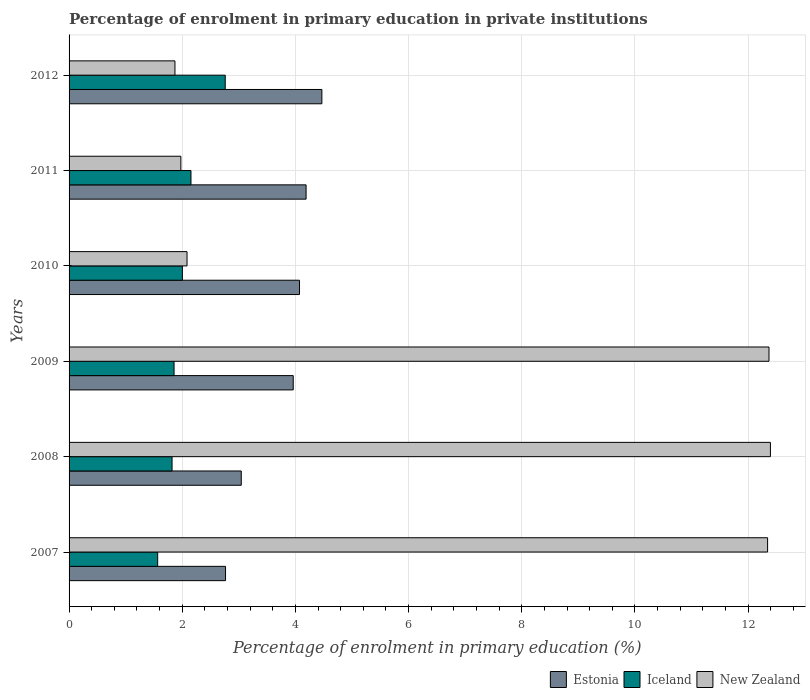How many groups of bars are there?
Your answer should be very brief. 6. Are the number of bars on each tick of the Y-axis equal?
Keep it short and to the point. Yes. In how many cases, is the number of bars for a given year not equal to the number of legend labels?
Ensure brevity in your answer.  0. What is the percentage of enrolment in primary education in New Zealand in 2007?
Make the answer very short. 12.34. Across all years, what is the maximum percentage of enrolment in primary education in Iceland?
Offer a very short reply. 2.76. Across all years, what is the minimum percentage of enrolment in primary education in Iceland?
Provide a short and direct response. 1.57. In which year was the percentage of enrolment in primary education in Estonia maximum?
Your response must be concise. 2012. In which year was the percentage of enrolment in primary education in Estonia minimum?
Keep it short and to the point. 2007. What is the total percentage of enrolment in primary education in Iceland in the graph?
Your answer should be compact. 12.16. What is the difference between the percentage of enrolment in primary education in Estonia in 2007 and that in 2012?
Keep it short and to the point. -1.7. What is the difference between the percentage of enrolment in primary education in Estonia in 2009 and the percentage of enrolment in primary education in New Zealand in 2008?
Your response must be concise. -8.43. What is the average percentage of enrolment in primary education in Estonia per year?
Keep it short and to the point. 3.75. In the year 2012, what is the difference between the percentage of enrolment in primary education in New Zealand and percentage of enrolment in primary education in Estonia?
Ensure brevity in your answer.  -2.6. What is the ratio of the percentage of enrolment in primary education in New Zealand in 2009 to that in 2012?
Keep it short and to the point. 6.61. What is the difference between the highest and the second highest percentage of enrolment in primary education in Iceland?
Ensure brevity in your answer.  0.61. What is the difference between the highest and the lowest percentage of enrolment in primary education in Estonia?
Your answer should be very brief. 1.7. In how many years, is the percentage of enrolment in primary education in Estonia greater than the average percentage of enrolment in primary education in Estonia taken over all years?
Offer a very short reply. 4. What does the 3rd bar from the bottom in 2011 represents?
Offer a very short reply. New Zealand. Is it the case that in every year, the sum of the percentage of enrolment in primary education in Iceland and percentage of enrolment in primary education in Estonia is greater than the percentage of enrolment in primary education in New Zealand?
Your response must be concise. No. What is the difference between two consecutive major ticks on the X-axis?
Make the answer very short. 2. Does the graph contain any zero values?
Your answer should be very brief. No. What is the title of the graph?
Give a very brief answer. Percentage of enrolment in primary education in private institutions. Does "Tanzania" appear as one of the legend labels in the graph?
Provide a succinct answer. No. What is the label or title of the X-axis?
Keep it short and to the point. Percentage of enrolment in primary education (%). What is the label or title of the Y-axis?
Your response must be concise. Years. What is the Percentage of enrolment in primary education (%) in Estonia in 2007?
Offer a very short reply. 2.76. What is the Percentage of enrolment in primary education (%) of Iceland in 2007?
Keep it short and to the point. 1.57. What is the Percentage of enrolment in primary education (%) in New Zealand in 2007?
Give a very brief answer. 12.34. What is the Percentage of enrolment in primary education (%) in Estonia in 2008?
Keep it short and to the point. 3.04. What is the Percentage of enrolment in primary education (%) in Iceland in 2008?
Provide a succinct answer. 1.82. What is the Percentage of enrolment in primary education (%) of New Zealand in 2008?
Your answer should be very brief. 12.39. What is the Percentage of enrolment in primary education (%) of Estonia in 2009?
Give a very brief answer. 3.96. What is the Percentage of enrolment in primary education (%) of Iceland in 2009?
Your response must be concise. 1.86. What is the Percentage of enrolment in primary education (%) in New Zealand in 2009?
Keep it short and to the point. 12.37. What is the Percentage of enrolment in primary education (%) in Estonia in 2010?
Your response must be concise. 4.07. What is the Percentage of enrolment in primary education (%) of Iceland in 2010?
Make the answer very short. 2. What is the Percentage of enrolment in primary education (%) in New Zealand in 2010?
Ensure brevity in your answer.  2.08. What is the Percentage of enrolment in primary education (%) in Estonia in 2011?
Keep it short and to the point. 4.19. What is the Percentage of enrolment in primary education (%) in Iceland in 2011?
Offer a terse response. 2.15. What is the Percentage of enrolment in primary education (%) of New Zealand in 2011?
Offer a terse response. 1.98. What is the Percentage of enrolment in primary education (%) in Estonia in 2012?
Provide a short and direct response. 4.47. What is the Percentage of enrolment in primary education (%) of Iceland in 2012?
Offer a very short reply. 2.76. What is the Percentage of enrolment in primary education (%) of New Zealand in 2012?
Your response must be concise. 1.87. Across all years, what is the maximum Percentage of enrolment in primary education (%) of Estonia?
Offer a terse response. 4.47. Across all years, what is the maximum Percentage of enrolment in primary education (%) of Iceland?
Make the answer very short. 2.76. Across all years, what is the maximum Percentage of enrolment in primary education (%) of New Zealand?
Provide a short and direct response. 12.39. Across all years, what is the minimum Percentage of enrolment in primary education (%) in Estonia?
Provide a short and direct response. 2.76. Across all years, what is the minimum Percentage of enrolment in primary education (%) in Iceland?
Your response must be concise. 1.57. Across all years, what is the minimum Percentage of enrolment in primary education (%) in New Zealand?
Offer a very short reply. 1.87. What is the total Percentage of enrolment in primary education (%) of Estonia in the graph?
Provide a succinct answer. 22.5. What is the total Percentage of enrolment in primary education (%) in Iceland in the graph?
Your answer should be compact. 12.16. What is the total Percentage of enrolment in primary education (%) in New Zealand in the graph?
Provide a short and direct response. 43.04. What is the difference between the Percentage of enrolment in primary education (%) in Estonia in 2007 and that in 2008?
Provide a short and direct response. -0.28. What is the difference between the Percentage of enrolment in primary education (%) of Iceland in 2007 and that in 2008?
Make the answer very short. -0.25. What is the difference between the Percentage of enrolment in primary education (%) in New Zealand in 2007 and that in 2008?
Give a very brief answer. -0.05. What is the difference between the Percentage of enrolment in primary education (%) of Estonia in 2007 and that in 2009?
Make the answer very short. -1.2. What is the difference between the Percentage of enrolment in primary education (%) in Iceland in 2007 and that in 2009?
Your answer should be compact. -0.29. What is the difference between the Percentage of enrolment in primary education (%) of New Zealand in 2007 and that in 2009?
Make the answer very short. -0.02. What is the difference between the Percentage of enrolment in primary education (%) of Estonia in 2007 and that in 2010?
Provide a short and direct response. -1.31. What is the difference between the Percentage of enrolment in primary education (%) of Iceland in 2007 and that in 2010?
Ensure brevity in your answer.  -0.44. What is the difference between the Percentage of enrolment in primary education (%) in New Zealand in 2007 and that in 2010?
Your answer should be compact. 10.26. What is the difference between the Percentage of enrolment in primary education (%) in Estonia in 2007 and that in 2011?
Ensure brevity in your answer.  -1.42. What is the difference between the Percentage of enrolment in primary education (%) of Iceland in 2007 and that in 2011?
Your response must be concise. -0.59. What is the difference between the Percentage of enrolment in primary education (%) of New Zealand in 2007 and that in 2011?
Provide a succinct answer. 10.37. What is the difference between the Percentage of enrolment in primary education (%) in Estonia in 2007 and that in 2012?
Keep it short and to the point. -1.7. What is the difference between the Percentage of enrolment in primary education (%) of Iceland in 2007 and that in 2012?
Give a very brief answer. -1.19. What is the difference between the Percentage of enrolment in primary education (%) in New Zealand in 2007 and that in 2012?
Offer a very short reply. 10.47. What is the difference between the Percentage of enrolment in primary education (%) in Estonia in 2008 and that in 2009?
Offer a terse response. -0.92. What is the difference between the Percentage of enrolment in primary education (%) of Iceland in 2008 and that in 2009?
Make the answer very short. -0.04. What is the difference between the Percentage of enrolment in primary education (%) in New Zealand in 2008 and that in 2009?
Ensure brevity in your answer.  0.03. What is the difference between the Percentage of enrolment in primary education (%) in Estonia in 2008 and that in 2010?
Give a very brief answer. -1.03. What is the difference between the Percentage of enrolment in primary education (%) in Iceland in 2008 and that in 2010?
Your answer should be compact. -0.18. What is the difference between the Percentage of enrolment in primary education (%) of New Zealand in 2008 and that in 2010?
Make the answer very short. 10.31. What is the difference between the Percentage of enrolment in primary education (%) of Estonia in 2008 and that in 2011?
Keep it short and to the point. -1.15. What is the difference between the Percentage of enrolment in primary education (%) in Iceland in 2008 and that in 2011?
Make the answer very short. -0.33. What is the difference between the Percentage of enrolment in primary education (%) of New Zealand in 2008 and that in 2011?
Make the answer very short. 10.42. What is the difference between the Percentage of enrolment in primary education (%) in Estonia in 2008 and that in 2012?
Ensure brevity in your answer.  -1.42. What is the difference between the Percentage of enrolment in primary education (%) of Iceland in 2008 and that in 2012?
Ensure brevity in your answer.  -0.94. What is the difference between the Percentage of enrolment in primary education (%) of New Zealand in 2008 and that in 2012?
Offer a terse response. 10.52. What is the difference between the Percentage of enrolment in primary education (%) in Estonia in 2009 and that in 2010?
Your response must be concise. -0.11. What is the difference between the Percentage of enrolment in primary education (%) of Iceland in 2009 and that in 2010?
Keep it short and to the point. -0.15. What is the difference between the Percentage of enrolment in primary education (%) of New Zealand in 2009 and that in 2010?
Make the answer very short. 10.28. What is the difference between the Percentage of enrolment in primary education (%) in Estonia in 2009 and that in 2011?
Provide a succinct answer. -0.23. What is the difference between the Percentage of enrolment in primary education (%) of Iceland in 2009 and that in 2011?
Provide a succinct answer. -0.3. What is the difference between the Percentage of enrolment in primary education (%) in New Zealand in 2009 and that in 2011?
Provide a succinct answer. 10.39. What is the difference between the Percentage of enrolment in primary education (%) of Estonia in 2009 and that in 2012?
Provide a succinct answer. -0.51. What is the difference between the Percentage of enrolment in primary education (%) of Iceland in 2009 and that in 2012?
Your answer should be very brief. -0.9. What is the difference between the Percentage of enrolment in primary education (%) of New Zealand in 2009 and that in 2012?
Ensure brevity in your answer.  10.5. What is the difference between the Percentage of enrolment in primary education (%) of Estonia in 2010 and that in 2011?
Give a very brief answer. -0.12. What is the difference between the Percentage of enrolment in primary education (%) of Iceland in 2010 and that in 2011?
Offer a very short reply. -0.15. What is the difference between the Percentage of enrolment in primary education (%) in New Zealand in 2010 and that in 2011?
Make the answer very short. 0.11. What is the difference between the Percentage of enrolment in primary education (%) in Estonia in 2010 and that in 2012?
Offer a terse response. -0.4. What is the difference between the Percentage of enrolment in primary education (%) in Iceland in 2010 and that in 2012?
Make the answer very short. -0.76. What is the difference between the Percentage of enrolment in primary education (%) in New Zealand in 2010 and that in 2012?
Your answer should be very brief. 0.21. What is the difference between the Percentage of enrolment in primary education (%) of Estonia in 2011 and that in 2012?
Give a very brief answer. -0.28. What is the difference between the Percentage of enrolment in primary education (%) of Iceland in 2011 and that in 2012?
Give a very brief answer. -0.61. What is the difference between the Percentage of enrolment in primary education (%) in New Zealand in 2011 and that in 2012?
Offer a terse response. 0.1. What is the difference between the Percentage of enrolment in primary education (%) in Estonia in 2007 and the Percentage of enrolment in primary education (%) in Iceland in 2008?
Offer a very short reply. 0.94. What is the difference between the Percentage of enrolment in primary education (%) in Estonia in 2007 and the Percentage of enrolment in primary education (%) in New Zealand in 2008?
Make the answer very short. -9.63. What is the difference between the Percentage of enrolment in primary education (%) in Iceland in 2007 and the Percentage of enrolment in primary education (%) in New Zealand in 2008?
Make the answer very short. -10.83. What is the difference between the Percentage of enrolment in primary education (%) in Estonia in 2007 and the Percentage of enrolment in primary education (%) in Iceland in 2009?
Provide a succinct answer. 0.91. What is the difference between the Percentage of enrolment in primary education (%) of Estonia in 2007 and the Percentage of enrolment in primary education (%) of New Zealand in 2009?
Your answer should be very brief. -9.6. What is the difference between the Percentage of enrolment in primary education (%) of Iceland in 2007 and the Percentage of enrolment in primary education (%) of New Zealand in 2009?
Provide a short and direct response. -10.8. What is the difference between the Percentage of enrolment in primary education (%) in Estonia in 2007 and the Percentage of enrolment in primary education (%) in Iceland in 2010?
Your answer should be very brief. 0.76. What is the difference between the Percentage of enrolment in primary education (%) in Estonia in 2007 and the Percentage of enrolment in primary education (%) in New Zealand in 2010?
Keep it short and to the point. 0.68. What is the difference between the Percentage of enrolment in primary education (%) of Iceland in 2007 and the Percentage of enrolment in primary education (%) of New Zealand in 2010?
Your answer should be compact. -0.52. What is the difference between the Percentage of enrolment in primary education (%) in Estonia in 2007 and the Percentage of enrolment in primary education (%) in Iceland in 2011?
Offer a very short reply. 0.61. What is the difference between the Percentage of enrolment in primary education (%) of Estonia in 2007 and the Percentage of enrolment in primary education (%) of New Zealand in 2011?
Provide a short and direct response. 0.79. What is the difference between the Percentage of enrolment in primary education (%) of Iceland in 2007 and the Percentage of enrolment in primary education (%) of New Zealand in 2011?
Provide a short and direct response. -0.41. What is the difference between the Percentage of enrolment in primary education (%) of Estonia in 2007 and the Percentage of enrolment in primary education (%) of Iceland in 2012?
Offer a terse response. 0.01. What is the difference between the Percentage of enrolment in primary education (%) of Estonia in 2007 and the Percentage of enrolment in primary education (%) of New Zealand in 2012?
Give a very brief answer. 0.89. What is the difference between the Percentage of enrolment in primary education (%) in Iceland in 2007 and the Percentage of enrolment in primary education (%) in New Zealand in 2012?
Give a very brief answer. -0.31. What is the difference between the Percentage of enrolment in primary education (%) of Estonia in 2008 and the Percentage of enrolment in primary education (%) of Iceland in 2009?
Ensure brevity in your answer.  1.19. What is the difference between the Percentage of enrolment in primary education (%) in Estonia in 2008 and the Percentage of enrolment in primary education (%) in New Zealand in 2009?
Make the answer very short. -9.33. What is the difference between the Percentage of enrolment in primary education (%) in Iceland in 2008 and the Percentage of enrolment in primary education (%) in New Zealand in 2009?
Ensure brevity in your answer.  -10.55. What is the difference between the Percentage of enrolment in primary education (%) in Estonia in 2008 and the Percentage of enrolment in primary education (%) in Iceland in 2010?
Make the answer very short. 1.04. What is the difference between the Percentage of enrolment in primary education (%) in Estonia in 2008 and the Percentage of enrolment in primary education (%) in New Zealand in 2010?
Your answer should be compact. 0.96. What is the difference between the Percentage of enrolment in primary education (%) of Iceland in 2008 and the Percentage of enrolment in primary education (%) of New Zealand in 2010?
Keep it short and to the point. -0.26. What is the difference between the Percentage of enrolment in primary education (%) in Estonia in 2008 and the Percentage of enrolment in primary education (%) in New Zealand in 2011?
Provide a short and direct response. 1.07. What is the difference between the Percentage of enrolment in primary education (%) in Iceland in 2008 and the Percentage of enrolment in primary education (%) in New Zealand in 2011?
Provide a succinct answer. -0.16. What is the difference between the Percentage of enrolment in primary education (%) in Estonia in 2008 and the Percentage of enrolment in primary education (%) in Iceland in 2012?
Offer a very short reply. 0.28. What is the difference between the Percentage of enrolment in primary education (%) in Estonia in 2008 and the Percentage of enrolment in primary education (%) in New Zealand in 2012?
Ensure brevity in your answer.  1.17. What is the difference between the Percentage of enrolment in primary education (%) in Iceland in 2008 and the Percentage of enrolment in primary education (%) in New Zealand in 2012?
Ensure brevity in your answer.  -0.05. What is the difference between the Percentage of enrolment in primary education (%) of Estonia in 2009 and the Percentage of enrolment in primary education (%) of Iceland in 2010?
Offer a terse response. 1.96. What is the difference between the Percentage of enrolment in primary education (%) in Estonia in 2009 and the Percentage of enrolment in primary education (%) in New Zealand in 2010?
Offer a very short reply. 1.88. What is the difference between the Percentage of enrolment in primary education (%) in Iceland in 2009 and the Percentage of enrolment in primary education (%) in New Zealand in 2010?
Provide a succinct answer. -0.23. What is the difference between the Percentage of enrolment in primary education (%) of Estonia in 2009 and the Percentage of enrolment in primary education (%) of Iceland in 2011?
Your answer should be compact. 1.81. What is the difference between the Percentage of enrolment in primary education (%) of Estonia in 2009 and the Percentage of enrolment in primary education (%) of New Zealand in 2011?
Give a very brief answer. 1.99. What is the difference between the Percentage of enrolment in primary education (%) in Iceland in 2009 and the Percentage of enrolment in primary education (%) in New Zealand in 2011?
Provide a short and direct response. -0.12. What is the difference between the Percentage of enrolment in primary education (%) in Estonia in 2009 and the Percentage of enrolment in primary education (%) in Iceland in 2012?
Make the answer very short. 1.2. What is the difference between the Percentage of enrolment in primary education (%) in Estonia in 2009 and the Percentage of enrolment in primary education (%) in New Zealand in 2012?
Your answer should be compact. 2.09. What is the difference between the Percentage of enrolment in primary education (%) of Iceland in 2009 and the Percentage of enrolment in primary education (%) of New Zealand in 2012?
Ensure brevity in your answer.  -0.02. What is the difference between the Percentage of enrolment in primary education (%) of Estonia in 2010 and the Percentage of enrolment in primary education (%) of Iceland in 2011?
Provide a short and direct response. 1.92. What is the difference between the Percentage of enrolment in primary education (%) of Estonia in 2010 and the Percentage of enrolment in primary education (%) of New Zealand in 2011?
Your answer should be very brief. 2.1. What is the difference between the Percentage of enrolment in primary education (%) of Iceland in 2010 and the Percentage of enrolment in primary education (%) of New Zealand in 2011?
Your answer should be compact. 0.03. What is the difference between the Percentage of enrolment in primary education (%) of Estonia in 2010 and the Percentage of enrolment in primary education (%) of Iceland in 2012?
Your answer should be very brief. 1.31. What is the difference between the Percentage of enrolment in primary education (%) in Estonia in 2010 and the Percentage of enrolment in primary education (%) in New Zealand in 2012?
Offer a terse response. 2.2. What is the difference between the Percentage of enrolment in primary education (%) of Iceland in 2010 and the Percentage of enrolment in primary education (%) of New Zealand in 2012?
Your response must be concise. 0.13. What is the difference between the Percentage of enrolment in primary education (%) in Estonia in 2011 and the Percentage of enrolment in primary education (%) in Iceland in 2012?
Your response must be concise. 1.43. What is the difference between the Percentage of enrolment in primary education (%) in Estonia in 2011 and the Percentage of enrolment in primary education (%) in New Zealand in 2012?
Make the answer very short. 2.32. What is the difference between the Percentage of enrolment in primary education (%) in Iceland in 2011 and the Percentage of enrolment in primary education (%) in New Zealand in 2012?
Make the answer very short. 0.28. What is the average Percentage of enrolment in primary education (%) in Estonia per year?
Provide a succinct answer. 3.75. What is the average Percentage of enrolment in primary education (%) in Iceland per year?
Your answer should be very brief. 2.03. What is the average Percentage of enrolment in primary education (%) in New Zealand per year?
Your response must be concise. 7.17. In the year 2007, what is the difference between the Percentage of enrolment in primary education (%) in Estonia and Percentage of enrolment in primary education (%) in Iceland?
Keep it short and to the point. 1.2. In the year 2007, what is the difference between the Percentage of enrolment in primary education (%) of Estonia and Percentage of enrolment in primary education (%) of New Zealand?
Your answer should be very brief. -9.58. In the year 2007, what is the difference between the Percentage of enrolment in primary education (%) of Iceland and Percentage of enrolment in primary education (%) of New Zealand?
Offer a terse response. -10.78. In the year 2008, what is the difference between the Percentage of enrolment in primary education (%) in Estonia and Percentage of enrolment in primary education (%) in Iceland?
Your response must be concise. 1.22. In the year 2008, what is the difference between the Percentage of enrolment in primary education (%) of Estonia and Percentage of enrolment in primary education (%) of New Zealand?
Offer a very short reply. -9.35. In the year 2008, what is the difference between the Percentage of enrolment in primary education (%) in Iceland and Percentage of enrolment in primary education (%) in New Zealand?
Offer a terse response. -10.57. In the year 2009, what is the difference between the Percentage of enrolment in primary education (%) in Estonia and Percentage of enrolment in primary education (%) in Iceland?
Make the answer very short. 2.11. In the year 2009, what is the difference between the Percentage of enrolment in primary education (%) in Estonia and Percentage of enrolment in primary education (%) in New Zealand?
Provide a short and direct response. -8.41. In the year 2009, what is the difference between the Percentage of enrolment in primary education (%) of Iceland and Percentage of enrolment in primary education (%) of New Zealand?
Offer a very short reply. -10.51. In the year 2010, what is the difference between the Percentage of enrolment in primary education (%) in Estonia and Percentage of enrolment in primary education (%) in Iceland?
Offer a terse response. 2.07. In the year 2010, what is the difference between the Percentage of enrolment in primary education (%) in Estonia and Percentage of enrolment in primary education (%) in New Zealand?
Make the answer very short. 1.99. In the year 2010, what is the difference between the Percentage of enrolment in primary education (%) in Iceland and Percentage of enrolment in primary education (%) in New Zealand?
Make the answer very short. -0.08. In the year 2011, what is the difference between the Percentage of enrolment in primary education (%) of Estonia and Percentage of enrolment in primary education (%) of Iceland?
Your answer should be very brief. 2.03. In the year 2011, what is the difference between the Percentage of enrolment in primary education (%) of Estonia and Percentage of enrolment in primary education (%) of New Zealand?
Offer a very short reply. 2.21. In the year 2011, what is the difference between the Percentage of enrolment in primary education (%) in Iceland and Percentage of enrolment in primary education (%) in New Zealand?
Keep it short and to the point. 0.18. In the year 2012, what is the difference between the Percentage of enrolment in primary education (%) in Estonia and Percentage of enrolment in primary education (%) in Iceland?
Provide a succinct answer. 1.71. In the year 2012, what is the difference between the Percentage of enrolment in primary education (%) of Estonia and Percentage of enrolment in primary education (%) of New Zealand?
Your response must be concise. 2.6. In the year 2012, what is the difference between the Percentage of enrolment in primary education (%) of Iceland and Percentage of enrolment in primary education (%) of New Zealand?
Give a very brief answer. 0.89. What is the ratio of the Percentage of enrolment in primary education (%) in Estonia in 2007 to that in 2008?
Provide a succinct answer. 0.91. What is the ratio of the Percentage of enrolment in primary education (%) of Iceland in 2007 to that in 2008?
Ensure brevity in your answer.  0.86. What is the ratio of the Percentage of enrolment in primary education (%) in New Zealand in 2007 to that in 2008?
Provide a short and direct response. 1. What is the ratio of the Percentage of enrolment in primary education (%) of Estonia in 2007 to that in 2009?
Your answer should be compact. 0.7. What is the ratio of the Percentage of enrolment in primary education (%) of Iceland in 2007 to that in 2009?
Your answer should be compact. 0.84. What is the ratio of the Percentage of enrolment in primary education (%) in Estonia in 2007 to that in 2010?
Your response must be concise. 0.68. What is the ratio of the Percentage of enrolment in primary education (%) of Iceland in 2007 to that in 2010?
Offer a terse response. 0.78. What is the ratio of the Percentage of enrolment in primary education (%) of New Zealand in 2007 to that in 2010?
Your answer should be compact. 5.92. What is the ratio of the Percentage of enrolment in primary education (%) of Estonia in 2007 to that in 2011?
Provide a succinct answer. 0.66. What is the ratio of the Percentage of enrolment in primary education (%) in Iceland in 2007 to that in 2011?
Provide a succinct answer. 0.73. What is the ratio of the Percentage of enrolment in primary education (%) in New Zealand in 2007 to that in 2011?
Provide a succinct answer. 6.25. What is the ratio of the Percentage of enrolment in primary education (%) of Estonia in 2007 to that in 2012?
Give a very brief answer. 0.62. What is the ratio of the Percentage of enrolment in primary education (%) in Iceland in 2007 to that in 2012?
Provide a short and direct response. 0.57. What is the ratio of the Percentage of enrolment in primary education (%) of New Zealand in 2007 to that in 2012?
Make the answer very short. 6.6. What is the ratio of the Percentage of enrolment in primary education (%) in Estonia in 2008 to that in 2009?
Your response must be concise. 0.77. What is the ratio of the Percentage of enrolment in primary education (%) of Estonia in 2008 to that in 2010?
Offer a terse response. 0.75. What is the ratio of the Percentage of enrolment in primary education (%) in Iceland in 2008 to that in 2010?
Your response must be concise. 0.91. What is the ratio of the Percentage of enrolment in primary education (%) in New Zealand in 2008 to that in 2010?
Offer a very short reply. 5.95. What is the ratio of the Percentage of enrolment in primary education (%) of Estonia in 2008 to that in 2011?
Give a very brief answer. 0.73. What is the ratio of the Percentage of enrolment in primary education (%) in Iceland in 2008 to that in 2011?
Provide a short and direct response. 0.84. What is the ratio of the Percentage of enrolment in primary education (%) in New Zealand in 2008 to that in 2011?
Your answer should be compact. 6.27. What is the ratio of the Percentage of enrolment in primary education (%) of Estonia in 2008 to that in 2012?
Your answer should be very brief. 0.68. What is the ratio of the Percentage of enrolment in primary education (%) of Iceland in 2008 to that in 2012?
Keep it short and to the point. 0.66. What is the ratio of the Percentage of enrolment in primary education (%) of New Zealand in 2008 to that in 2012?
Your response must be concise. 6.62. What is the ratio of the Percentage of enrolment in primary education (%) in Estonia in 2009 to that in 2010?
Ensure brevity in your answer.  0.97. What is the ratio of the Percentage of enrolment in primary education (%) in Iceland in 2009 to that in 2010?
Your answer should be compact. 0.93. What is the ratio of the Percentage of enrolment in primary education (%) in New Zealand in 2009 to that in 2010?
Provide a short and direct response. 5.93. What is the ratio of the Percentage of enrolment in primary education (%) in Estonia in 2009 to that in 2011?
Provide a short and direct response. 0.95. What is the ratio of the Percentage of enrolment in primary education (%) in Iceland in 2009 to that in 2011?
Your answer should be very brief. 0.86. What is the ratio of the Percentage of enrolment in primary education (%) in New Zealand in 2009 to that in 2011?
Provide a short and direct response. 6.26. What is the ratio of the Percentage of enrolment in primary education (%) in Estonia in 2009 to that in 2012?
Keep it short and to the point. 0.89. What is the ratio of the Percentage of enrolment in primary education (%) in Iceland in 2009 to that in 2012?
Give a very brief answer. 0.67. What is the ratio of the Percentage of enrolment in primary education (%) in New Zealand in 2009 to that in 2012?
Your answer should be very brief. 6.61. What is the ratio of the Percentage of enrolment in primary education (%) of Estonia in 2010 to that in 2011?
Provide a succinct answer. 0.97. What is the ratio of the Percentage of enrolment in primary education (%) of Iceland in 2010 to that in 2011?
Offer a very short reply. 0.93. What is the ratio of the Percentage of enrolment in primary education (%) in New Zealand in 2010 to that in 2011?
Ensure brevity in your answer.  1.06. What is the ratio of the Percentage of enrolment in primary education (%) of Estonia in 2010 to that in 2012?
Make the answer very short. 0.91. What is the ratio of the Percentage of enrolment in primary education (%) in Iceland in 2010 to that in 2012?
Give a very brief answer. 0.73. What is the ratio of the Percentage of enrolment in primary education (%) of New Zealand in 2010 to that in 2012?
Give a very brief answer. 1.11. What is the ratio of the Percentage of enrolment in primary education (%) in Estonia in 2011 to that in 2012?
Provide a succinct answer. 0.94. What is the ratio of the Percentage of enrolment in primary education (%) in Iceland in 2011 to that in 2012?
Ensure brevity in your answer.  0.78. What is the ratio of the Percentage of enrolment in primary education (%) of New Zealand in 2011 to that in 2012?
Ensure brevity in your answer.  1.06. What is the difference between the highest and the second highest Percentage of enrolment in primary education (%) in Estonia?
Ensure brevity in your answer.  0.28. What is the difference between the highest and the second highest Percentage of enrolment in primary education (%) in Iceland?
Your answer should be very brief. 0.61. What is the difference between the highest and the second highest Percentage of enrolment in primary education (%) in New Zealand?
Make the answer very short. 0.03. What is the difference between the highest and the lowest Percentage of enrolment in primary education (%) in Estonia?
Ensure brevity in your answer.  1.7. What is the difference between the highest and the lowest Percentage of enrolment in primary education (%) of Iceland?
Make the answer very short. 1.19. What is the difference between the highest and the lowest Percentage of enrolment in primary education (%) in New Zealand?
Ensure brevity in your answer.  10.52. 